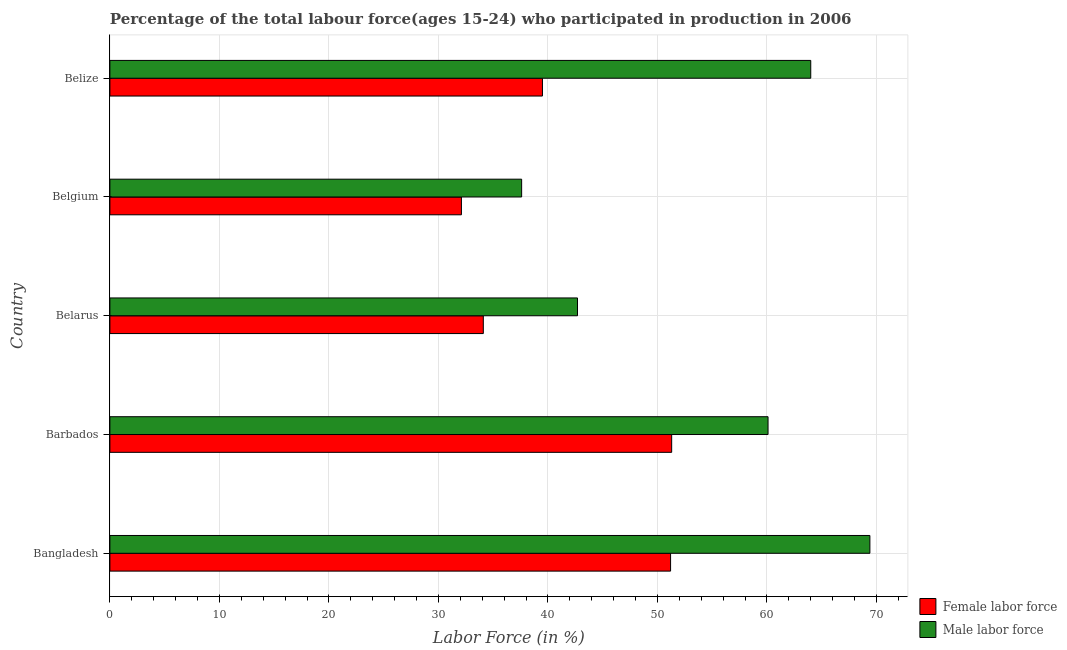Are the number of bars per tick equal to the number of legend labels?
Keep it short and to the point. Yes. Are the number of bars on each tick of the Y-axis equal?
Your answer should be compact. Yes. How many bars are there on the 2nd tick from the bottom?
Your response must be concise. 2. What is the label of the 3rd group of bars from the top?
Ensure brevity in your answer.  Belarus. What is the percentage of female labor force in Barbados?
Make the answer very short. 51.3. Across all countries, what is the maximum percentage of male labour force?
Provide a short and direct response. 69.4. Across all countries, what is the minimum percentage of female labor force?
Give a very brief answer. 32.1. In which country was the percentage of female labor force maximum?
Give a very brief answer. Barbados. What is the total percentage of female labor force in the graph?
Your answer should be compact. 208.2. What is the difference between the percentage of female labor force in Bangladesh and that in Belgium?
Offer a very short reply. 19.1. What is the difference between the percentage of female labor force in Barbados and the percentage of male labour force in Belarus?
Offer a terse response. 8.6. What is the average percentage of female labor force per country?
Offer a terse response. 41.64. What is the ratio of the percentage of female labor force in Belgium to that in Belize?
Provide a succinct answer. 0.81. Is the difference between the percentage of male labour force in Belgium and Belize greater than the difference between the percentage of female labor force in Belgium and Belize?
Ensure brevity in your answer.  No. Is the sum of the percentage of male labour force in Belarus and Belize greater than the maximum percentage of female labor force across all countries?
Keep it short and to the point. Yes. What does the 1st bar from the top in Belarus represents?
Provide a succinct answer. Male labor force. What does the 2nd bar from the bottom in Belarus represents?
Provide a succinct answer. Male labor force. How many bars are there?
Your response must be concise. 10. How many countries are there in the graph?
Keep it short and to the point. 5. Where does the legend appear in the graph?
Make the answer very short. Bottom right. How many legend labels are there?
Make the answer very short. 2. What is the title of the graph?
Offer a very short reply. Percentage of the total labour force(ages 15-24) who participated in production in 2006. What is the label or title of the Y-axis?
Provide a succinct answer. Country. What is the Labor Force (in %) of Female labor force in Bangladesh?
Provide a succinct answer. 51.2. What is the Labor Force (in %) of Male labor force in Bangladesh?
Your response must be concise. 69.4. What is the Labor Force (in %) in Female labor force in Barbados?
Provide a succinct answer. 51.3. What is the Labor Force (in %) of Male labor force in Barbados?
Ensure brevity in your answer.  60.1. What is the Labor Force (in %) of Female labor force in Belarus?
Provide a succinct answer. 34.1. What is the Labor Force (in %) of Male labor force in Belarus?
Provide a succinct answer. 42.7. What is the Labor Force (in %) in Female labor force in Belgium?
Give a very brief answer. 32.1. What is the Labor Force (in %) of Male labor force in Belgium?
Your response must be concise. 37.6. What is the Labor Force (in %) of Female labor force in Belize?
Give a very brief answer. 39.5. Across all countries, what is the maximum Labor Force (in %) in Female labor force?
Offer a very short reply. 51.3. Across all countries, what is the maximum Labor Force (in %) of Male labor force?
Your answer should be very brief. 69.4. Across all countries, what is the minimum Labor Force (in %) of Female labor force?
Your response must be concise. 32.1. Across all countries, what is the minimum Labor Force (in %) in Male labor force?
Keep it short and to the point. 37.6. What is the total Labor Force (in %) of Female labor force in the graph?
Your answer should be very brief. 208.2. What is the total Labor Force (in %) of Male labor force in the graph?
Give a very brief answer. 273.8. What is the difference between the Labor Force (in %) in Male labor force in Bangladesh and that in Belarus?
Offer a very short reply. 26.7. What is the difference between the Labor Force (in %) of Male labor force in Bangladesh and that in Belgium?
Your response must be concise. 31.8. What is the difference between the Labor Force (in %) of Male labor force in Bangladesh and that in Belize?
Provide a short and direct response. 5.4. What is the difference between the Labor Force (in %) of Female labor force in Barbados and that in Belize?
Offer a terse response. 11.8. What is the difference between the Labor Force (in %) of Male labor force in Barbados and that in Belize?
Provide a succinct answer. -3.9. What is the difference between the Labor Force (in %) of Female labor force in Belarus and that in Belgium?
Your answer should be compact. 2. What is the difference between the Labor Force (in %) in Male labor force in Belarus and that in Belgium?
Keep it short and to the point. 5.1. What is the difference between the Labor Force (in %) of Male labor force in Belarus and that in Belize?
Your answer should be compact. -21.3. What is the difference between the Labor Force (in %) in Female labor force in Belgium and that in Belize?
Provide a succinct answer. -7.4. What is the difference between the Labor Force (in %) of Male labor force in Belgium and that in Belize?
Your response must be concise. -26.4. What is the difference between the Labor Force (in %) of Female labor force in Bangladesh and the Labor Force (in %) of Male labor force in Belarus?
Your response must be concise. 8.5. What is the difference between the Labor Force (in %) of Female labor force in Bangladesh and the Labor Force (in %) of Male labor force in Belize?
Give a very brief answer. -12.8. What is the difference between the Labor Force (in %) in Female labor force in Barbados and the Labor Force (in %) in Male labor force in Belgium?
Offer a very short reply. 13.7. What is the difference between the Labor Force (in %) in Female labor force in Barbados and the Labor Force (in %) in Male labor force in Belize?
Your answer should be very brief. -12.7. What is the difference between the Labor Force (in %) in Female labor force in Belarus and the Labor Force (in %) in Male labor force in Belgium?
Offer a terse response. -3.5. What is the difference between the Labor Force (in %) of Female labor force in Belarus and the Labor Force (in %) of Male labor force in Belize?
Ensure brevity in your answer.  -29.9. What is the difference between the Labor Force (in %) in Female labor force in Belgium and the Labor Force (in %) in Male labor force in Belize?
Your answer should be very brief. -31.9. What is the average Labor Force (in %) in Female labor force per country?
Your answer should be very brief. 41.64. What is the average Labor Force (in %) of Male labor force per country?
Keep it short and to the point. 54.76. What is the difference between the Labor Force (in %) of Female labor force and Labor Force (in %) of Male labor force in Bangladesh?
Offer a very short reply. -18.2. What is the difference between the Labor Force (in %) in Female labor force and Labor Force (in %) in Male labor force in Barbados?
Your answer should be very brief. -8.8. What is the difference between the Labor Force (in %) of Female labor force and Labor Force (in %) of Male labor force in Belgium?
Your answer should be compact. -5.5. What is the difference between the Labor Force (in %) in Female labor force and Labor Force (in %) in Male labor force in Belize?
Your answer should be compact. -24.5. What is the ratio of the Labor Force (in %) in Female labor force in Bangladesh to that in Barbados?
Your answer should be very brief. 1. What is the ratio of the Labor Force (in %) of Male labor force in Bangladesh to that in Barbados?
Your answer should be very brief. 1.15. What is the ratio of the Labor Force (in %) in Female labor force in Bangladesh to that in Belarus?
Ensure brevity in your answer.  1.5. What is the ratio of the Labor Force (in %) in Male labor force in Bangladesh to that in Belarus?
Provide a succinct answer. 1.63. What is the ratio of the Labor Force (in %) in Female labor force in Bangladesh to that in Belgium?
Your answer should be compact. 1.59. What is the ratio of the Labor Force (in %) in Male labor force in Bangladesh to that in Belgium?
Your answer should be very brief. 1.85. What is the ratio of the Labor Force (in %) of Female labor force in Bangladesh to that in Belize?
Give a very brief answer. 1.3. What is the ratio of the Labor Force (in %) of Male labor force in Bangladesh to that in Belize?
Your response must be concise. 1.08. What is the ratio of the Labor Force (in %) in Female labor force in Barbados to that in Belarus?
Your response must be concise. 1.5. What is the ratio of the Labor Force (in %) of Male labor force in Barbados to that in Belarus?
Ensure brevity in your answer.  1.41. What is the ratio of the Labor Force (in %) of Female labor force in Barbados to that in Belgium?
Give a very brief answer. 1.6. What is the ratio of the Labor Force (in %) in Male labor force in Barbados to that in Belgium?
Provide a succinct answer. 1.6. What is the ratio of the Labor Force (in %) of Female labor force in Barbados to that in Belize?
Provide a short and direct response. 1.3. What is the ratio of the Labor Force (in %) in Male labor force in Barbados to that in Belize?
Make the answer very short. 0.94. What is the ratio of the Labor Force (in %) in Female labor force in Belarus to that in Belgium?
Offer a very short reply. 1.06. What is the ratio of the Labor Force (in %) of Male labor force in Belarus to that in Belgium?
Your response must be concise. 1.14. What is the ratio of the Labor Force (in %) of Female labor force in Belarus to that in Belize?
Your answer should be very brief. 0.86. What is the ratio of the Labor Force (in %) in Male labor force in Belarus to that in Belize?
Offer a terse response. 0.67. What is the ratio of the Labor Force (in %) of Female labor force in Belgium to that in Belize?
Give a very brief answer. 0.81. What is the ratio of the Labor Force (in %) in Male labor force in Belgium to that in Belize?
Ensure brevity in your answer.  0.59. What is the difference between the highest and the second highest Labor Force (in %) of Male labor force?
Provide a succinct answer. 5.4. What is the difference between the highest and the lowest Labor Force (in %) of Female labor force?
Ensure brevity in your answer.  19.2. What is the difference between the highest and the lowest Labor Force (in %) of Male labor force?
Ensure brevity in your answer.  31.8. 